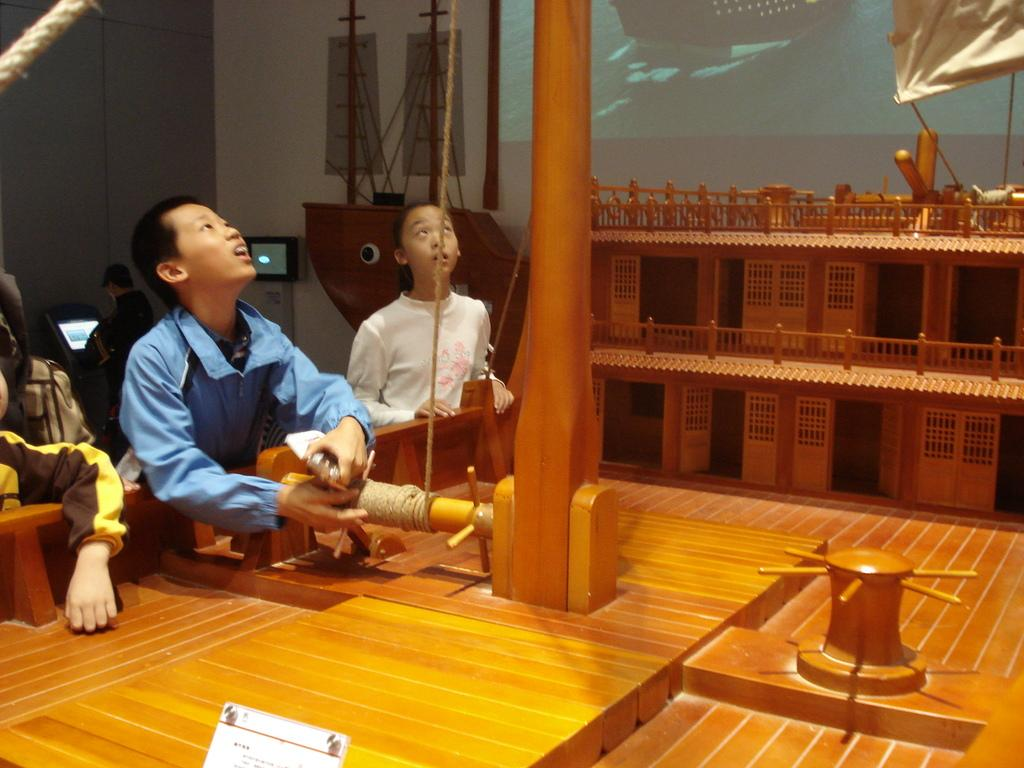What can be seen on the children in the image? The children are wearing clothes in the image. What type of flooring is visible in the image? There is a wooden floor in the image. What object can be used for climbing or swinging in the image? There is a rope and a pole in the image, which can be used for climbing or swinging. What is being projected onto a surface in the image? There is a projected screen in the image. What type of structure is present in the image? There is a small wooden house in the image. What type of health advice can be seen on the projected screen in the image? There is no health advice visible on the projected screen in the image. 